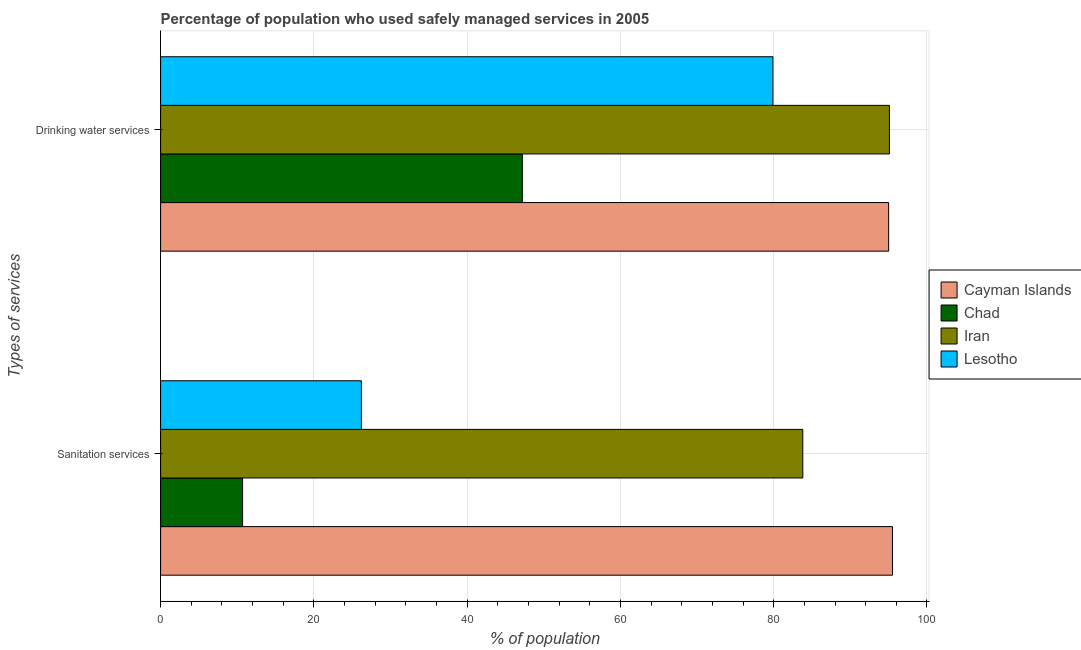How many different coloured bars are there?
Your response must be concise. 4. How many bars are there on the 2nd tick from the top?
Your answer should be very brief. 4. How many bars are there on the 2nd tick from the bottom?
Give a very brief answer. 4. What is the label of the 2nd group of bars from the top?
Keep it short and to the point. Sanitation services. What is the percentage of population who used drinking water services in Iran?
Your response must be concise. 95.1. Across all countries, what is the maximum percentage of population who used drinking water services?
Your response must be concise. 95.1. Across all countries, what is the minimum percentage of population who used sanitation services?
Your response must be concise. 10.7. In which country was the percentage of population who used sanitation services maximum?
Ensure brevity in your answer.  Cayman Islands. In which country was the percentage of population who used drinking water services minimum?
Provide a succinct answer. Chad. What is the total percentage of population who used sanitation services in the graph?
Your response must be concise. 216.2. What is the difference between the percentage of population who used sanitation services in Chad and that in Lesotho?
Provide a succinct answer. -15.5. What is the difference between the percentage of population who used sanitation services in Iran and the percentage of population who used drinking water services in Lesotho?
Give a very brief answer. 3.9. What is the average percentage of population who used sanitation services per country?
Offer a very short reply. 54.05. What is the difference between the percentage of population who used sanitation services and percentage of population who used drinking water services in Iran?
Ensure brevity in your answer.  -11.3. In how many countries, is the percentage of population who used sanitation services greater than 96 %?
Give a very brief answer. 0. What is the ratio of the percentage of population who used drinking water services in Chad to that in Cayman Islands?
Offer a terse response. 0.5. In how many countries, is the percentage of population who used drinking water services greater than the average percentage of population who used drinking water services taken over all countries?
Offer a very short reply. 3. What does the 1st bar from the top in Sanitation services represents?
Provide a succinct answer. Lesotho. What does the 3rd bar from the bottom in Sanitation services represents?
Keep it short and to the point. Iran. How many bars are there?
Provide a succinct answer. 8. Are all the bars in the graph horizontal?
Provide a succinct answer. Yes. How many countries are there in the graph?
Keep it short and to the point. 4. What is the difference between two consecutive major ticks on the X-axis?
Provide a short and direct response. 20. Does the graph contain any zero values?
Give a very brief answer. No. Where does the legend appear in the graph?
Offer a terse response. Center right. How many legend labels are there?
Keep it short and to the point. 4. How are the legend labels stacked?
Give a very brief answer. Vertical. What is the title of the graph?
Provide a short and direct response. Percentage of population who used safely managed services in 2005. Does "Sudan" appear as one of the legend labels in the graph?
Offer a very short reply. No. What is the label or title of the X-axis?
Your answer should be compact. % of population. What is the label or title of the Y-axis?
Your answer should be compact. Types of services. What is the % of population in Cayman Islands in Sanitation services?
Give a very brief answer. 95.5. What is the % of population of Iran in Sanitation services?
Your answer should be very brief. 83.8. What is the % of population in Lesotho in Sanitation services?
Provide a short and direct response. 26.2. What is the % of population of Chad in Drinking water services?
Your response must be concise. 47.2. What is the % of population in Iran in Drinking water services?
Your answer should be very brief. 95.1. What is the % of population in Lesotho in Drinking water services?
Your answer should be very brief. 79.9. Across all Types of services, what is the maximum % of population of Cayman Islands?
Offer a terse response. 95.5. Across all Types of services, what is the maximum % of population of Chad?
Offer a very short reply. 47.2. Across all Types of services, what is the maximum % of population of Iran?
Offer a terse response. 95.1. Across all Types of services, what is the maximum % of population in Lesotho?
Your response must be concise. 79.9. Across all Types of services, what is the minimum % of population of Cayman Islands?
Offer a terse response. 95. Across all Types of services, what is the minimum % of population in Iran?
Your response must be concise. 83.8. Across all Types of services, what is the minimum % of population of Lesotho?
Provide a short and direct response. 26.2. What is the total % of population in Cayman Islands in the graph?
Make the answer very short. 190.5. What is the total % of population of Chad in the graph?
Provide a short and direct response. 57.9. What is the total % of population of Iran in the graph?
Ensure brevity in your answer.  178.9. What is the total % of population in Lesotho in the graph?
Give a very brief answer. 106.1. What is the difference between the % of population in Cayman Islands in Sanitation services and that in Drinking water services?
Give a very brief answer. 0.5. What is the difference between the % of population of Chad in Sanitation services and that in Drinking water services?
Provide a short and direct response. -36.5. What is the difference between the % of population of Lesotho in Sanitation services and that in Drinking water services?
Make the answer very short. -53.7. What is the difference between the % of population of Cayman Islands in Sanitation services and the % of population of Chad in Drinking water services?
Your answer should be compact. 48.3. What is the difference between the % of population in Cayman Islands in Sanitation services and the % of population in Iran in Drinking water services?
Give a very brief answer. 0.4. What is the difference between the % of population in Cayman Islands in Sanitation services and the % of population in Lesotho in Drinking water services?
Keep it short and to the point. 15.6. What is the difference between the % of population of Chad in Sanitation services and the % of population of Iran in Drinking water services?
Your response must be concise. -84.4. What is the difference between the % of population of Chad in Sanitation services and the % of population of Lesotho in Drinking water services?
Provide a succinct answer. -69.2. What is the average % of population of Cayman Islands per Types of services?
Give a very brief answer. 95.25. What is the average % of population of Chad per Types of services?
Your answer should be very brief. 28.95. What is the average % of population in Iran per Types of services?
Provide a succinct answer. 89.45. What is the average % of population in Lesotho per Types of services?
Give a very brief answer. 53.05. What is the difference between the % of population in Cayman Islands and % of population in Chad in Sanitation services?
Offer a terse response. 84.8. What is the difference between the % of population in Cayman Islands and % of population in Iran in Sanitation services?
Provide a succinct answer. 11.7. What is the difference between the % of population of Cayman Islands and % of population of Lesotho in Sanitation services?
Your response must be concise. 69.3. What is the difference between the % of population in Chad and % of population in Iran in Sanitation services?
Make the answer very short. -73.1. What is the difference between the % of population in Chad and % of population in Lesotho in Sanitation services?
Your answer should be compact. -15.5. What is the difference between the % of population in Iran and % of population in Lesotho in Sanitation services?
Give a very brief answer. 57.6. What is the difference between the % of population of Cayman Islands and % of population of Chad in Drinking water services?
Your answer should be very brief. 47.8. What is the difference between the % of population of Chad and % of population of Iran in Drinking water services?
Your answer should be compact. -47.9. What is the difference between the % of population in Chad and % of population in Lesotho in Drinking water services?
Ensure brevity in your answer.  -32.7. What is the ratio of the % of population of Chad in Sanitation services to that in Drinking water services?
Provide a short and direct response. 0.23. What is the ratio of the % of population in Iran in Sanitation services to that in Drinking water services?
Provide a succinct answer. 0.88. What is the ratio of the % of population in Lesotho in Sanitation services to that in Drinking water services?
Make the answer very short. 0.33. What is the difference between the highest and the second highest % of population in Cayman Islands?
Your answer should be very brief. 0.5. What is the difference between the highest and the second highest % of population in Chad?
Provide a succinct answer. 36.5. What is the difference between the highest and the second highest % of population of Iran?
Your response must be concise. 11.3. What is the difference between the highest and the second highest % of population of Lesotho?
Give a very brief answer. 53.7. What is the difference between the highest and the lowest % of population of Cayman Islands?
Your answer should be compact. 0.5. What is the difference between the highest and the lowest % of population in Chad?
Offer a terse response. 36.5. What is the difference between the highest and the lowest % of population in Lesotho?
Keep it short and to the point. 53.7. 